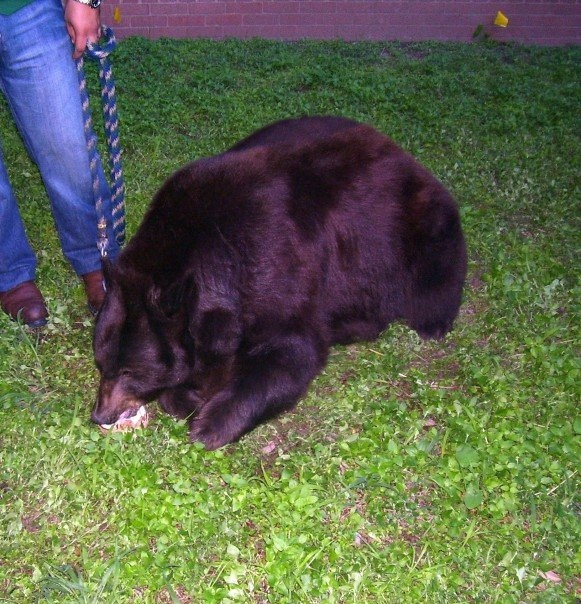Describe the objects in this image and their specific colors. I can see bear in teal, black, and purple tones and people in teal, blue, and navy tones in this image. 